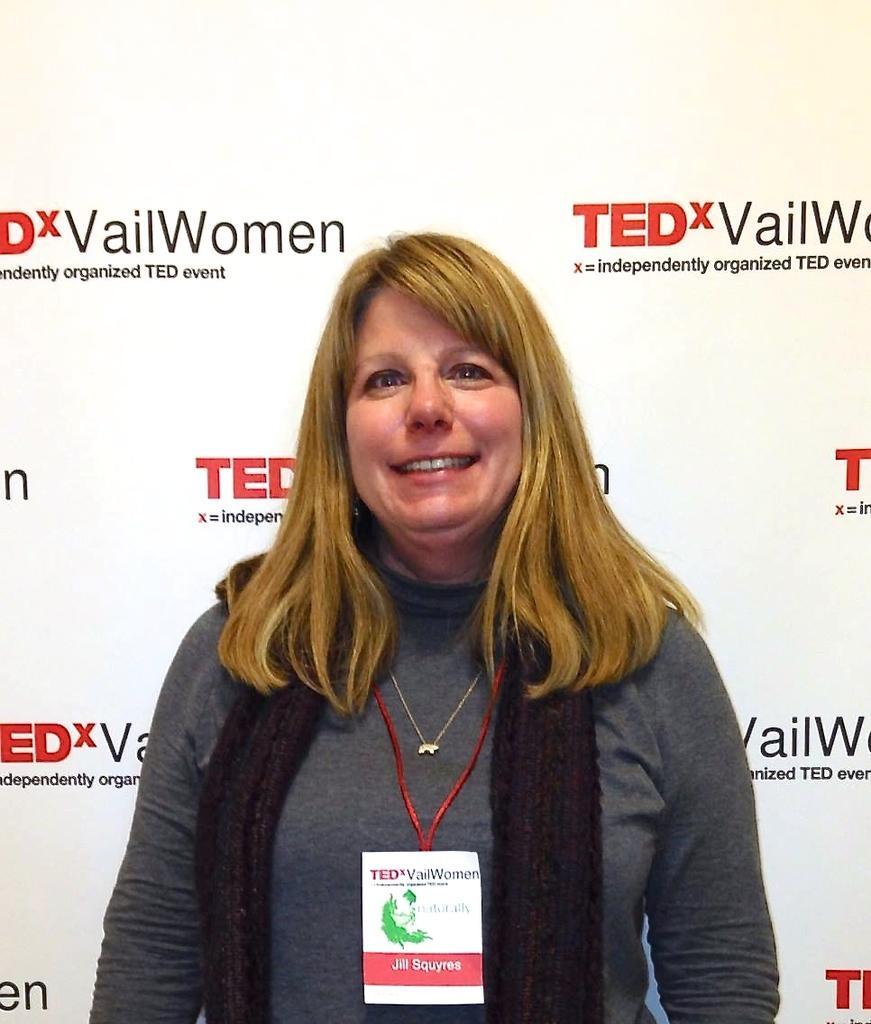Please provide a concise description of this image. In this image I can see a woman is standing in the front and I can see she is wearing an ID card, a necklace and grey colour dress. I can also see smile on her face. In the background I can see a white colour thing and on it I can see something is written. 